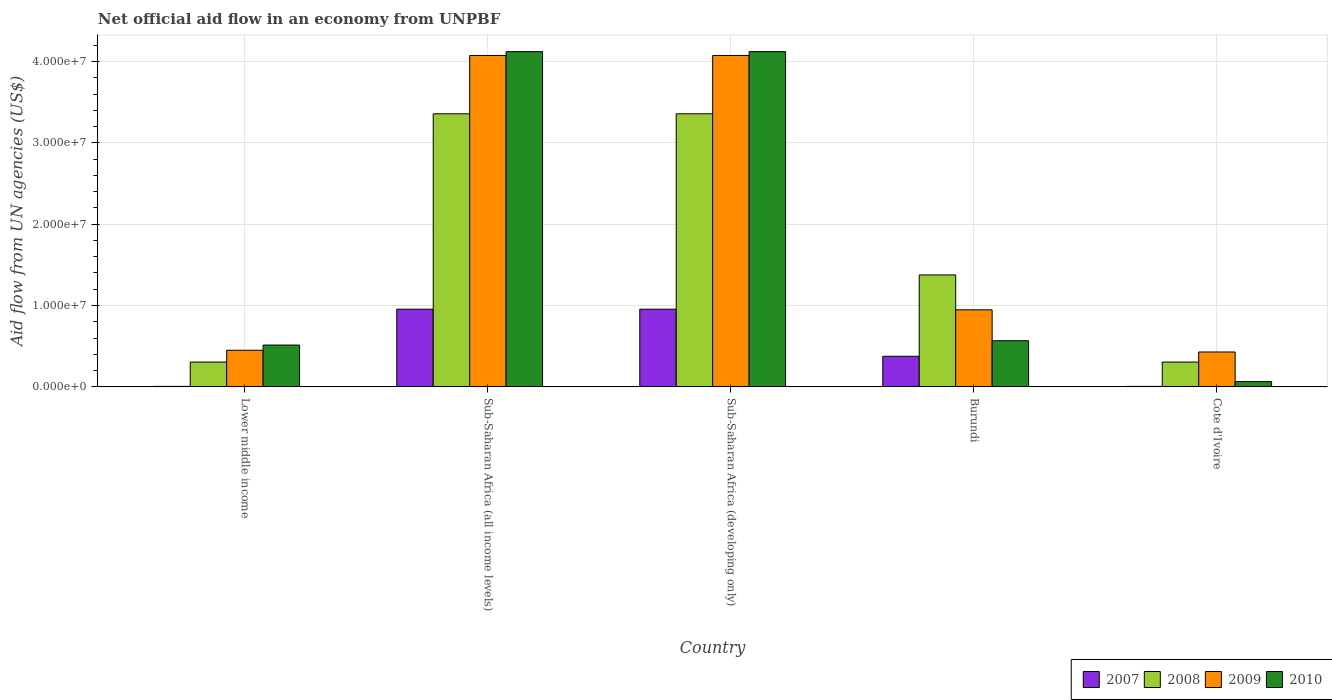How many different coloured bars are there?
Your response must be concise. 4. Are the number of bars per tick equal to the number of legend labels?
Your answer should be compact. Yes. Are the number of bars on each tick of the X-axis equal?
Make the answer very short. Yes. How many bars are there on the 5th tick from the left?
Offer a very short reply. 4. How many bars are there on the 3rd tick from the right?
Offer a very short reply. 4. What is the label of the 1st group of bars from the left?
Provide a short and direct response. Lower middle income. In how many cases, is the number of bars for a given country not equal to the number of legend labels?
Make the answer very short. 0. What is the net official aid flow in 2010 in Burundi?
Make the answer very short. 5.67e+06. Across all countries, what is the maximum net official aid flow in 2010?
Give a very brief answer. 4.12e+07. Across all countries, what is the minimum net official aid flow in 2010?
Your response must be concise. 6.50e+05. In which country was the net official aid flow in 2010 maximum?
Make the answer very short. Sub-Saharan Africa (all income levels). In which country was the net official aid flow in 2008 minimum?
Provide a succinct answer. Lower middle income. What is the total net official aid flow in 2008 in the graph?
Offer a very short reply. 8.70e+07. What is the difference between the net official aid flow in 2009 in Burundi and that in Lower middle income?
Offer a terse response. 4.97e+06. What is the difference between the net official aid flow in 2008 in Sub-Saharan Africa (all income levels) and the net official aid flow in 2009 in Lower middle income?
Make the answer very short. 2.91e+07. What is the average net official aid flow in 2009 per country?
Provide a short and direct response. 1.99e+07. What is the difference between the net official aid flow of/in 2010 and net official aid flow of/in 2007 in Sub-Saharan Africa (developing only)?
Your response must be concise. 3.17e+07. In how many countries, is the net official aid flow in 2007 greater than 6000000 US$?
Ensure brevity in your answer.  2. What is the ratio of the net official aid flow in 2008 in Burundi to that in Sub-Saharan Africa (developing only)?
Provide a short and direct response. 0.41. Is the net official aid flow in 2010 in Cote d'Ivoire less than that in Sub-Saharan Africa (all income levels)?
Your answer should be very brief. Yes. Is the difference between the net official aid flow in 2010 in Burundi and Sub-Saharan Africa (developing only) greater than the difference between the net official aid flow in 2007 in Burundi and Sub-Saharan Africa (developing only)?
Offer a terse response. No. What is the difference between the highest and the second highest net official aid flow in 2009?
Provide a short and direct response. 3.13e+07. What is the difference between the highest and the lowest net official aid flow in 2008?
Your answer should be compact. 3.05e+07. In how many countries, is the net official aid flow in 2007 greater than the average net official aid flow in 2007 taken over all countries?
Make the answer very short. 2. What does the 2nd bar from the left in Sub-Saharan Africa (developing only) represents?
Your answer should be very brief. 2008. What does the 3rd bar from the right in Burundi represents?
Make the answer very short. 2008. Is it the case that in every country, the sum of the net official aid flow in 2010 and net official aid flow in 2009 is greater than the net official aid flow in 2008?
Offer a terse response. Yes. How many bars are there?
Offer a terse response. 20. What is the difference between two consecutive major ticks on the Y-axis?
Provide a short and direct response. 1.00e+07. Are the values on the major ticks of Y-axis written in scientific E-notation?
Provide a succinct answer. Yes. Does the graph contain any zero values?
Provide a short and direct response. No. Does the graph contain grids?
Give a very brief answer. Yes. How are the legend labels stacked?
Ensure brevity in your answer.  Horizontal. What is the title of the graph?
Make the answer very short. Net official aid flow in an economy from UNPBF. What is the label or title of the X-axis?
Give a very brief answer. Country. What is the label or title of the Y-axis?
Your answer should be very brief. Aid flow from UN agencies (US$). What is the Aid flow from UN agencies (US$) of 2008 in Lower middle income?
Make the answer very short. 3.05e+06. What is the Aid flow from UN agencies (US$) of 2009 in Lower middle income?
Make the answer very short. 4.50e+06. What is the Aid flow from UN agencies (US$) of 2010 in Lower middle income?
Make the answer very short. 5.14e+06. What is the Aid flow from UN agencies (US$) of 2007 in Sub-Saharan Africa (all income levels)?
Your answer should be compact. 9.55e+06. What is the Aid flow from UN agencies (US$) in 2008 in Sub-Saharan Africa (all income levels)?
Your answer should be compact. 3.36e+07. What is the Aid flow from UN agencies (US$) in 2009 in Sub-Saharan Africa (all income levels)?
Offer a terse response. 4.07e+07. What is the Aid flow from UN agencies (US$) of 2010 in Sub-Saharan Africa (all income levels)?
Your answer should be very brief. 4.12e+07. What is the Aid flow from UN agencies (US$) in 2007 in Sub-Saharan Africa (developing only)?
Keep it short and to the point. 9.55e+06. What is the Aid flow from UN agencies (US$) of 2008 in Sub-Saharan Africa (developing only)?
Provide a short and direct response. 3.36e+07. What is the Aid flow from UN agencies (US$) in 2009 in Sub-Saharan Africa (developing only)?
Your answer should be compact. 4.07e+07. What is the Aid flow from UN agencies (US$) in 2010 in Sub-Saharan Africa (developing only)?
Keep it short and to the point. 4.12e+07. What is the Aid flow from UN agencies (US$) of 2007 in Burundi?
Ensure brevity in your answer.  3.76e+06. What is the Aid flow from UN agencies (US$) in 2008 in Burundi?
Your answer should be very brief. 1.38e+07. What is the Aid flow from UN agencies (US$) in 2009 in Burundi?
Provide a short and direct response. 9.47e+06. What is the Aid flow from UN agencies (US$) of 2010 in Burundi?
Your answer should be very brief. 5.67e+06. What is the Aid flow from UN agencies (US$) of 2007 in Cote d'Ivoire?
Offer a very short reply. 6.00e+04. What is the Aid flow from UN agencies (US$) in 2008 in Cote d'Ivoire?
Ensure brevity in your answer.  3.05e+06. What is the Aid flow from UN agencies (US$) of 2009 in Cote d'Ivoire?
Your answer should be very brief. 4.29e+06. What is the Aid flow from UN agencies (US$) in 2010 in Cote d'Ivoire?
Provide a succinct answer. 6.50e+05. Across all countries, what is the maximum Aid flow from UN agencies (US$) in 2007?
Offer a terse response. 9.55e+06. Across all countries, what is the maximum Aid flow from UN agencies (US$) of 2008?
Provide a short and direct response. 3.36e+07. Across all countries, what is the maximum Aid flow from UN agencies (US$) of 2009?
Offer a terse response. 4.07e+07. Across all countries, what is the maximum Aid flow from UN agencies (US$) in 2010?
Keep it short and to the point. 4.12e+07. Across all countries, what is the minimum Aid flow from UN agencies (US$) of 2008?
Your answer should be very brief. 3.05e+06. Across all countries, what is the minimum Aid flow from UN agencies (US$) in 2009?
Keep it short and to the point. 4.29e+06. Across all countries, what is the minimum Aid flow from UN agencies (US$) of 2010?
Your answer should be compact. 6.50e+05. What is the total Aid flow from UN agencies (US$) in 2007 in the graph?
Your response must be concise. 2.30e+07. What is the total Aid flow from UN agencies (US$) in 2008 in the graph?
Offer a very short reply. 8.70e+07. What is the total Aid flow from UN agencies (US$) of 2009 in the graph?
Your answer should be compact. 9.97e+07. What is the total Aid flow from UN agencies (US$) in 2010 in the graph?
Give a very brief answer. 9.39e+07. What is the difference between the Aid flow from UN agencies (US$) of 2007 in Lower middle income and that in Sub-Saharan Africa (all income levels)?
Provide a succinct answer. -9.49e+06. What is the difference between the Aid flow from UN agencies (US$) of 2008 in Lower middle income and that in Sub-Saharan Africa (all income levels)?
Your response must be concise. -3.05e+07. What is the difference between the Aid flow from UN agencies (US$) of 2009 in Lower middle income and that in Sub-Saharan Africa (all income levels)?
Ensure brevity in your answer.  -3.62e+07. What is the difference between the Aid flow from UN agencies (US$) of 2010 in Lower middle income and that in Sub-Saharan Africa (all income levels)?
Keep it short and to the point. -3.61e+07. What is the difference between the Aid flow from UN agencies (US$) of 2007 in Lower middle income and that in Sub-Saharan Africa (developing only)?
Provide a short and direct response. -9.49e+06. What is the difference between the Aid flow from UN agencies (US$) of 2008 in Lower middle income and that in Sub-Saharan Africa (developing only)?
Give a very brief answer. -3.05e+07. What is the difference between the Aid flow from UN agencies (US$) of 2009 in Lower middle income and that in Sub-Saharan Africa (developing only)?
Make the answer very short. -3.62e+07. What is the difference between the Aid flow from UN agencies (US$) in 2010 in Lower middle income and that in Sub-Saharan Africa (developing only)?
Your answer should be compact. -3.61e+07. What is the difference between the Aid flow from UN agencies (US$) in 2007 in Lower middle income and that in Burundi?
Offer a very short reply. -3.70e+06. What is the difference between the Aid flow from UN agencies (US$) in 2008 in Lower middle income and that in Burundi?
Your answer should be very brief. -1.07e+07. What is the difference between the Aid flow from UN agencies (US$) of 2009 in Lower middle income and that in Burundi?
Your answer should be very brief. -4.97e+06. What is the difference between the Aid flow from UN agencies (US$) of 2010 in Lower middle income and that in Burundi?
Your response must be concise. -5.30e+05. What is the difference between the Aid flow from UN agencies (US$) of 2007 in Lower middle income and that in Cote d'Ivoire?
Make the answer very short. 0. What is the difference between the Aid flow from UN agencies (US$) in 2010 in Lower middle income and that in Cote d'Ivoire?
Provide a succinct answer. 4.49e+06. What is the difference between the Aid flow from UN agencies (US$) of 2007 in Sub-Saharan Africa (all income levels) and that in Sub-Saharan Africa (developing only)?
Your response must be concise. 0. What is the difference between the Aid flow from UN agencies (US$) in 2009 in Sub-Saharan Africa (all income levels) and that in Sub-Saharan Africa (developing only)?
Keep it short and to the point. 0. What is the difference between the Aid flow from UN agencies (US$) in 2007 in Sub-Saharan Africa (all income levels) and that in Burundi?
Your answer should be very brief. 5.79e+06. What is the difference between the Aid flow from UN agencies (US$) in 2008 in Sub-Saharan Africa (all income levels) and that in Burundi?
Provide a succinct answer. 1.98e+07. What is the difference between the Aid flow from UN agencies (US$) of 2009 in Sub-Saharan Africa (all income levels) and that in Burundi?
Ensure brevity in your answer.  3.13e+07. What is the difference between the Aid flow from UN agencies (US$) of 2010 in Sub-Saharan Africa (all income levels) and that in Burundi?
Your answer should be compact. 3.55e+07. What is the difference between the Aid flow from UN agencies (US$) of 2007 in Sub-Saharan Africa (all income levels) and that in Cote d'Ivoire?
Your answer should be compact. 9.49e+06. What is the difference between the Aid flow from UN agencies (US$) of 2008 in Sub-Saharan Africa (all income levels) and that in Cote d'Ivoire?
Keep it short and to the point. 3.05e+07. What is the difference between the Aid flow from UN agencies (US$) of 2009 in Sub-Saharan Africa (all income levels) and that in Cote d'Ivoire?
Offer a terse response. 3.64e+07. What is the difference between the Aid flow from UN agencies (US$) in 2010 in Sub-Saharan Africa (all income levels) and that in Cote d'Ivoire?
Keep it short and to the point. 4.06e+07. What is the difference between the Aid flow from UN agencies (US$) of 2007 in Sub-Saharan Africa (developing only) and that in Burundi?
Provide a succinct answer. 5.79e+06. What is the difference between the Aid flow from UN agencies (US$) of 2008 in Sub-Saharan Africa (developing only) and that in Burundi?
Provide a short and direct response. 1.98e+07. What is the difference between the Aid flow from UN agencies (US$) in 2009 in Sub-Saharan Africa (developing only) and that in Burundi?
Your answer should be compact. 3.13e+07. What is the difference between the Aid flow from UN agencies (US$) of 2010 in Sub-Saharan Africa (developing only) and that in Burundi?
Ensure brevity in your answer.  3.55e+07. What is the difference between the Aid flow from UN agencies (US$) in 2007 in Sub-Saharan Africa (developing only) and that in Cote d'Ivoire?
Offer a terse response. 9.49e+06. What is the difference between the Aid flow from UN agencies (US$) in 2008 in Sub-Saharan Africa (developing only) and that in Cote d'Ivoire?
Your response must be concise. 3.05e+07. What is the difference between the Aid flow from UN agencies (US$) in 2009 in Sub-Saharan Africa (developing only) and that in Cote d'Ivoire?
Ensure brevity in your answer.  3.64e+07. What is the difference between the Aid flow from UN agencies (US$) in 2010 in Sub-Saharan Africa (developing only) and that in Cote d'Ivoire?
Make the answer very short. 4.06e+07. What is the difference between the Aid flow from UN agencies (US$) in 2007 in Burundi and that in Cote d'Ivoire?
Keep it short and to the point. 3.70e+06. What is the difference between the Aid flow from UN agencies (US$) of 2008 in Burundi and that in Cote d'Ivoire?
Offer a very short reply. 1.07e+07. What is the difference between the Aid flow from UN agencies (US$) in 2009 in Burundi and that in Cote d'Ivoire?
Provide a short and direct response. 5.18e+06. What is the difference between the Aid flow from UN agencies (US$) in 2010 in Burundi and that in Cote d'Ivoire?
Your answer should be very brief. 5.02e+06. What is the difference between the Aid flow from UN agencies (US$) in 2007 in Lower middle income and the Aid flow from UN agencies (US$) in 2008 in Sub-Saharan Africa (all income levels)?
Provide a succinct answer. -3.35e+07. What is the difference between the Aid flow from UN agencies (US$) of 2007 in Lower middle income and the Aid flow from UN agencies (US$) of 2009 in Sub-Saharan Africa (all income levels)?
Your answer should be very brief. -4.07e+07. What is the difference between the Aid flow from UN agencies (US$) of 2007 in Lower middle income and the Aid flow from UN agencies (US$) of 2010 in Sub-Saharan Africa (all income levels)?
Provide a short and direct response. -4.12e+07. What is the difference between the Aid flow from UN agencies (US$) of 2008 in Lower middle income and the Aid flow from UN agencies (US$) of 2009 in Sub-Saharan Africa (all income levels)?
Your answer should be very brief. -3.77e+07. What is the difference between the Aid flow from UN agencies (US$) in 2008 in Lower middle income and the Aid flow from UN agencies (US$) in 2010 in Sub-Saharan Africa (all income levels)?
Offer a terse response. -3.82e+07. What is the difference between the Aid flow from UN agencies (US$) in 2009 in Lower middle income and the Aid flow from UN agencies (US$) in 2010 in Sub-Saharan Africa (all income levels)?
Make the answer very short. -3.67e+07. What is the difference between the Aid flow from UN agencies (US$) in 2007 in Lower middle income and the Aid flow from UN agencies (US$) in 2008 in Sub-Saharan Africa (developing only)?
Give a very brief answer. -3.35e+07. What is the difference between the Aid flow from UN agencies (US$) in 2007 in Lower middle income and the Aid flow from UN agencies (US$) in 2009 in Sub-Saharan Africa (developing only)?
Make the answer very short. -4.07e+07. What is the difference between the Aid flow from UN agencies (US$) in 2007 in Lower middle income and the Aid flow from UN agencies (US$) in 2010 in Sub-Saharan Africa (developing only)?
Provide a short and direct response. -4.12e+07. What is the difference between the Aid flow from UN agencies (US$) in 2008 in Lower middle income and the Aid flow from UN agencies (US$) in 2009 in Sub-Saharan Africa (developing only)?
Ensure brevity in your answer.  -3.77e+07. What is the difference between the Aid flow from UN agencies (US$) in 2008 in Lower middle income and the Aid flow from UN agencies (US$) in 2010 in Sub-Saharan Africa (developing only)?
Keep it short and to the point. -3.82e+07. What is the difference between the Aid flow from UN agencies (US$) of 2009 in Lower middle income and the Aid flow from UN agencies (US$) of 2010 in Sub-Saharan Africa (developing only)?
Give a very brief answer. -3.67e+07. What is the difference between the Aid flow from UN agencies (US$) of 2007 in Lower middle income and the Aid flow from UN agencies (US$) of 2008 in Burundi?
Your answer should be very brief. -1.37e+07. What is the difference between the Aid flow from UN agencies (US$) of 2007 in Lower middle income and the Aid flow from UN agencies (US$) of 2009 in Burundi?
Offer a very short reply. -9.41e+06. What is the difference between the Aid flow from UN agencies (US$) of 2007 in Lower middle income and the Aid flow from UN agencies (US$) of 2010 in Burundi?
Offer a very short reply. -5.61e+06. What is the difference between the Aid flow from UN agencies (US$) in 2008 in Lower middle income and the Aid flow from UN agencies (US$) in 2009 in Burundi?
Make the answer very short. -6.42e+06. What is the difference between the Aid flow from UN agencies (US$) of 2008 in Lower middle income and the Aid flow from UN agencies (US$) of 2010 in Burundi?
Your answer should be compact. -2.62e+06. What is the difference between the Aid flow from UN agencies (US$) of 2009 in Lower middle income and the Aid flow from UN agencies (US$) of 2010 in Burundi?
Offer a very short reply. -1.17e+06. What is the difference between the Aid flow from UN agencies (US$) in 2007 in Lower middle income and the Aid flow from UN agencies (US$) in 2008 in Cote d'Ivoire?
Make the answer very short. -2.99e+06. What is the difference between the Aid flow from UN agencies (US$) in 2007 in Lower middle income and the Aid flow from UN agencies (US$) in 2009 in Cote d'Ivoire?
Keep it short and to the point. -4.23e+06. What is the difference between the Aid flow from UN agencies (US$) in 2007 in Lower middle income and the Aid flow from UN agencies (US$) in 2010 in Cote d'Ivoire?
Ensure brevity in your answer.  -5.90e+05. What is the difference between the Aid flow from UN agencies (US$) of 2008 in Lower middle income and the Aid flow from UN agencies (US$) of 2009 in Cote d'Ivoire?
Give a very brief answer. -1.24e+06. What is the difference between the Aid flow from UN agencies (US$) in 2008 in Lower middle income and the Aid flow from UN agencies (US$) in 2010 in Cote d'Ivoire?
Ensure brevity in your answer.  2.40e+06. What is the difference between the Aid flow from UN agencies (US$) in 2009 in Lower middle income and the Aid flow from UN agencies (US$) in 2010 in Cote d'Ivoire?
Ensure brevity in your answer.  3.85e+06. What is the difference between the Aid flow from UN agencies (US$) of 2007 in Sub-Saharan Africa (all income levels) and the Aid flow from UN agencies (US$) of 2008 in Sub-Saharan Africa (developing only)?
Provide a succinct answer. -2.40e+07. What is the difference between the Aid flow from UN agencies (US$) of 2007 in Sub-Saharan Africa (all income levels) and the Aid flow from UN agencies (US$) of 2009 in Sub-Saharan Africa (developing only)?
Make the answer very short. -3.12e+07. What is the difference between the Aid flow from UN agencies (US$) in 2007 in Sub-Saharan Africa (all income levels) and the Aid flow from UN agencies (US$) in 2010 in Sub-Saharan Africa (developing only)?
Your answer should be compact. -3.17e+07. What is the difference between the Aid flow from UN agencies (US$) of 2008 in Sub-Saharan Africa (all income levels) and the Aid flow from UN agencies (US$) of 2009 in Sub-Saharan Africa (developing only)?
Provide a succinct answer. -7.17e+06. What is the difference between the Aid flow from UN agencies (US$) of 2008 in Sub-Saharan Africa (all income levels) and the Aid flow from UN agencies (US$) of 2010 in Sub-Saharan Africa (developing only)?
Your answer should be very brief. -7.64e+06. What is the difference between the Aid flow from UN agencies (US$) in 2009 in Sub-Saharan Africa (all income levels) and the Aid flow from UN agencies (US$) in 2010 in Sub-Saharan Africa (developing only)?
Ensure brevity in your answer.  -4.70e+05. What is the difference between the Aid flow from UN agencies (US$) of 2007 in Sub-Saharan Africa (all income levels) and the Aid flow from UN agencies (US$) of 2008 in Burundi?
Your answer should be compact. -4.21e+06. What is the difference between the Aid flow from UN agencies (US$) in 2007 in Sub-Saharan Africa (all income levels) and the Aid flow from UN agencies (US$) in 2009 in Burundi?
Your response must be concise. 8.00e+04. What is the difference between the Aid flow from UN agencies (US$) in 2007 in Sub-Saharan Africa (all income levels) and the Aid flow from UN agencies (US$) in 2010 in Burundi?
Your answer should be very brief. 3.88e+06. What is the difference between the Aid flow from UN agencies (US$) in 2008 in Sub-Saharan Africa (all income levels) and the Aid flow from UN agencies (US$) in 2009 in Burundi?
Give a very brief answer. 2.41e+07. What is the difference between the Aid flow from UN agencies (US$) in 2008 in Sub-Saharan Africa (all income levels) and the Aid flow from UN agencies (US$) in 2010 in Burundi?
Your answer should be very brief. 2.79e+07. What is the difference between the Aid flow from UN agencies (US$) of 2009 in Sub-Saharan Africa (all income levels) and the Aid flow from UN agencies (US$) of 2010 in Burundi?
Your response must be concise. 3.51e+07. What is the difference between the Aid flow from UN agencies (US$) in 2007 in Sub-Saharan Africa (all income levels) and the Aid flow from UN agencies (US$) in 2008 in Cote d'Ivoire?
Keep it short and to the point. 6.50e+06. What is the difference between the Aid flow from UN agencies (US$) in 2007 in Sub-Saharan Africa (all income levels) and the Aid flow from UN agencies (US$) in 2009 in Cote d'Ivoire?
Offer a terse response. 5.26e+06. What is the difference between the Aid flow from UN agencies (US$) in 2007 in Sub-Saharan Africa (all income levels) and the Aid flow from UN agencies (US$) in 2010 in Cote d'Ivoire?
Give a very brief answer. 8.90e+06. What is the difference between the Aid flow from UN agencies (US$) in 2008 in Sub-Saharan Africa (all income levels) and the Aid flow from UN agencies (US$) in 2009 in Cote d'Ivoire?
Give a very brief answer. 2.93e+07. What is the difference between the Aid flow from UN agencies (US$) of 2008 in Sub-Saharan Africa (all income levels) and the Aid flow from UN agencies (US$) of 2010 in Cote d'Ivoire?
Offer a very short reply. 3.29e+07. What is the difference between the Aid flow from UN agencies (US$) of 2009 in Sub-Saharan Africa (all income levels) and the Aid flow from UN agencies (US$) of 2010 in Cote d'Ivoire?
Your response must be concise. 4.01e+07. What is the difference between the Aid flow from UN agencies (US$) in 2007 in Sub-Saharan Africa (developing only) and the Aid flow from UN agencies (US$) in 2008 in Burundi?
Your answer should be compact. -4.21e+06. What is the difference between the Aid flow from UN agencies (US$) in 2007 in Sub-Saharan Africa (developing only) and the Aid flow from UN agencies (US$) in 2010 in Burundi?
Make the answer very short. 3.88e+06. What is the difference between the Aid flow from UN agencies (US$) in 2008 in Sub-Saharan Africa (developing only) and the Aid flow from UN agencies (US$) in 2009 in Burundi?
Your answer should be very brief. 2.41e+07. What is the difference between the Aid flow from UN agencies (US$) in 2008 in Sub-Saharan Africa (developing only) and the Aid flow from UN agencies (US$) in 2010 in Burundi?
Provide a short and direct response. 2.79e+07. What is the difference between the Aid flow from UN agencies (US$) of 2009 in Sub-Saharan Africa (developing only) and the Aid flow from UN agencies (US$) of 2010 in Burundi?
Offer a terse response. 3.51e+07. What is the difference between the Aid flow from UN agencies (US$) of 2007 in Sub-Saharan Africa (developing only) and the Aid flow from UN agencies (US$) of 2008 in Cote d'Ivoire?
Your answer should be very brief. 6.50e+06. What is the difference between the Aid flow from UN agencies (US$) of 2007 in Sub-Saharan Africa (developing only) and the Aid flow from UN agencies (US$) of 2009 in Cote d'Ivoire?
Keep it short and to the point. 5.26e+06. What is the difference between the Aid flow from UN agencies (US$) in 2007 in Sub-Saharan Africa (developing only) and the Aid flow from UN agencies (US$) in 2010 in Cote d'Ivoire?
Ensure brevity in your answer.  8.90e+06. What is the difference between the Aid flow from UN agencies (US$) of 2008 in Sub-Saharan Africa (developing only) and the Aid flow from UN agencies (US$) of 2009 in Cote d'Ivoire?
Your response must be concise. 2.93e+07. What is the difference between the Aid flow from UN agencies (US$) in 2008 in Sub-Saharan Africa (developing only) and the Aid flow from UN agencies (US$) in 2010 in Cote d'Ivoire?
Your response must be concise. 3.29e+07. What is the difference between the Aid flow from UN agencies (US$) in 2009 in Sub-Saharan Africa (developing only) and the Aid flow from UN agencies (US$) in 2010 in Cote d'Ivoire?
Keep it short and to the point. 4.01e+07. What is the difference between the Aid flow from UN agencies (US$) in 2007 in Burundi and the Aid flow from UN agencies (US$) in 2008 in Cote d'Ivoire?
Keep it short and to the point. 7.10e+05. What is the difference between the Aid flow from UN agencies (US$) in 2007 in Burundi and the Aid flow from UN agencies (US$) in 2009 in Cote d'Ivoire?
Your response must be concise. -5.30e+05. What is the difference between the Aid flow from UN agencies (US$) of 2007 in Burundi and the Aid flow from UN agencies (US$) of 2010 in Cote d'Ivoire?
Your answer should be very brief. 3.11e+06. What is the difference between the Aid flow from UN agencies (US$) in 2008 in Burundi and the Aid flow from UN agencies (US$) in 2009 in Cote d'Ivoire?
Your response must be concise. 9.47e+06. What is the difference between the Aid flow from UN agencies (US$) in 2008 in Burundi and the Aid flow from UN agencies (US$) in 2010 in Cote d'Ivoire?
Your answer should be compact. 1.31e+07. What is the difference between the Aid flow from UN agencies (US$) in 2009 in Burundi and the Aid flow from UN agencies (US$) in 2010 in Cote d'Ivoire?
Ensure brevity in your answer.  8.82e+06. What is the average Aid flow from UN agencies (US$) in 2007 per country?
Give a very brief answer. 4.60e+06. What is the average Aid flow from UN agencies (US$) of 2008 per country?
Offer a terse response. 1.74e+07. What is the average Aid flow from UN agencies (US$) in 2009 per country?
Offer a terse response. 1.99e+07. What is the average Aid flow from UN agencies (US$) of 2010 per country?
Your response must be concise. 1.88e+07. What is the difference between the Aid flow from UN agencies (US$) in 2007 and Aid flow from UN agencies (US$) in 2008 in Lower middle income?
Offer a terse response. -2.99e+06. What is the difference between the Aid flow from UN agencies (US$) in 2007 and Aid flow from UN agencies (US$) in 2009 in Lower middle income?
Give a very brief answer. -4.44e+06. What is the difference between the Aid flow from UN agencies (US$) in 2007 and Aid flow from UN agencies (US$) in 2010 in Lower middle income?
Offer a terse response. -5.08e+06. What is the difference between the Aid flow from UN agencies (US$) of 2008 and Aid flow from UN agencies (US$) of 2009 in Lower middle income?
Your response must be concise. -1.45e+06. What is the difference between the Aid flow from UN agencies (US$) in 2008 and Aid flow from UN agencies (US$) in 2010 in Lower middle income?
Offer a very short reply. -2.09e+06. What is the difference between the Aid flow from UN agencies (US$) in 2009 and Aid flow from UN agencies (US$) in 2010 in Lower middle income?
Provide a short and direct response. -6.40e+05. What is the difference between the Aid flow from UN agencies (US$) in 2007 and Aid flow from UN agencies (US$) in 2008 in Sub-Saharan Africa (all income levels)?
Give a very brief answer. -2.40e+07. What is the difference between the Aid flow from UN agencies (US$) of 2007 and Aid flow from UN agencies (US$) of 2009 in Sub-Saharan Africa (all income levels)?
Your answer should be compact. -3.12e+07. What is the difference between the Aid flow from UN agencies (US$) of 2007 and Aid flow from UN agencies (US$) of 2010 in Sub-Saharan Africa (all income levels)?
Give a very brief answer. -3.17e+07. What is the difference between the Aid flow from UN agencies (US$) in 2008 and Aid flow from UN agencies (US$) in 2009 in Sub-Saharan Africa (all income levels)?
Ensure brevity in your answer.  -7.17e+06. What is the difference between the Aid flow from UN agencies (US$) of 2008 and Aid flow from UN agencies (US$) of 2010 in Sub-Saharan Africa (all income levels)?
Make the answer very short. -7.64e+06. What is the difference between the Aid flow from UN agencies (US$) of 2009 and Aid flow from UN agencies (US$) of 2010 in Sub-Saharan Africa (all income levels)?
Your answer should be very brief. -4.70e+05. What is the difference between the Aid flow from UN agencies (US$) in 2007 and Aid flow from UN agencies (US$) in 2008 in Sub-Saharan Africa (developing only)?
Give a very brief answer. -2.40e+07. What is the difference between the Aid flow from UN agencies (US$) of 2007 and Aid flow from UN agencies (US$) of 2009 in Sub-Saharan Africa (developing only)?
Offer a terse response. -3.12e+07. What is the difference between the Aid flow from UN agencies (US$) of 2007 and Aid flow from UN agencies (US$) of 2010 in Sub-Saharan Africa (developing only)?
Offer a terse response. -3.17e+07. What is the difference between the Aid flow from UN agencies (US$) of 2008 and Aid flow from UN agencies (US$) of 2009 in Sub-Saharan Africa (developing only)?
Your answer should be compact. -7.17e+06. What is the difference between the Aid flow from UN agencies (US$) in 2008 and Aid flow from UN agencies (US$) in 2010 in Sub-Saharan Africa (developing only)?
Your answer should be compact. -7.64e+06. What is the difference between the Aid flow from UN agencies (US$) of 2009 and Aid flow from UN agencies (US$) of 2010 in Sub-Saharan Africa (developing only)?
Provide a succinct answer. -4.70e+05. What is the difference between the Aid flow from UN agencies (US$) of 2007 and Aid flow from UN agencies (US$) of 2008 in Burundi?
Ensure brevity in your answer.  -1.00e+07. What is the difference between the Aid flow from UN agencies (US$) of 2007 and Aid flow from UN agencies (US$) of 2009 in Burundi?
Keep it short and to the point. -5.71e+06. What is the difference between the Aid flow from UN agencies (US$) of 2007 and Aid flow from UN agencies (US$) of 2010 in Burundi?
Offer a terse response. -1.91e+06. What is the difference between the Aid flow from UN agencies (US$) of 2008 and Aid flow from UN agencies (US$) of 2009 in Burundi?
Your answer should be very brief. 4.29e+06. What is the difference between the Aid flow from UN agencies (US$) of 2008 and Aid flow from UN agencies (US$) of 2010 in Burundi?
Provide a short and direct response. 8.09e+06. What is the difference between the Aid flow from UN agencies (US$) of 2009 and Aid flow from UN agencies (US$) of 2010 in Burundi?
Your response must be concise. 3.80e+06. What is the difference between the Aid flow from UN agencies (US$) of 2007 and Aid flow from UN agencies (US$) of 2008 in Cote d'Ivoire?
Provide a succinct answer. -2.99e+06. What is the difference between the Aid flow from UN agencies (US$) of 2007 and Aid flow from UN agencies (US$) of 2009 in Cote d'Ivoire?
Offer a terse response. -4.23e+06. What is the difference between the Aid flow from UN agencies (US$) of 2007 and Aid flow from UN agencies (US$) of 2010 in Cote d'Ivoire?
Make the answer very short. -5.90e+05. What is the difference between the Aid flow from UN agencies (US$) of 2008 and Aid flow from UN agencies (US$) of 2009 in Cote d'Ivoire?
Make the answer very short. -1.24e+06. What is the difference between the Aid flow from UN agencies (US$) in 2008 and Aid flow from UN agencies (US$) in 2010 in Cote d'Ivoire?
Give a very brief answer. 2.40e+06. What is the difference between the Aid flow from UN agencies (US$) in 2009 and Aid flow from UN agencies (US$) in 2010 in Cote d'Ivoire?
Offer a very short reply. 3.64e+06. What is the ratio of the Aid flow from UN agencies (US$) of 2007 in Lower middle income to that in Sub-Saharan Africa (all income levels)?
Keep it short and to the point. 0.01. What is the ratio of the Aid flow from UN agencies (US$) of 2008 in Lower middle income to that in Sub-Saharan Africa (all income levels)?
Make the answer very short. 0.09. What is the ratio of the Aid flow from UN agencies (US$) of 2009 in Lower middle income to that in Sub-Saharan Africa (all income levels)?
Make the answer very short. 0.11. What is the ratio of the Aid flow from UN agencies (US$) in 2010 in Lower middle income to that in Sub-Saharan Africa (all income levels)?
Offer a terse response. 0.12. What is the ratio of the Aid flow from UN agencies (US$) of 2007 in Lower middle income to that in Sub-Saharan Africa (developing only)?
Your answer should be very brief. 0.01. What is the ratio of the Aid flow from UN agencies (US$) in 2008 in Lower middle income to that in Sub-Saharan Africa (developing only)?
Your answer should be compact. 0.09. What is the ratio of the Aid flow from UN agencies (US$) of 2009 in Lower middle income to that in Sub-Saharan Africa (developing only)?
Offer a very short reply. 0.11. What is the ratio of the Aid flow from UN agencies (US$) of 2010 in Lower middle income to that in Sub-Saharan Africa (developing only)?
Give a very brief answer. 0.12. What is the ratio of the Aid flow from UN agencies (US$) in 2007 in Lower middle income to that in Burundi?
Make the answer very short. 0.02. What is the ratio of the Aid flow from UN agencies (US$) of 2008 in Lower middle income to that in Burundi?
Ensure brevity in your answer.  0.22. What is the ratio of the Aid flow from UN agencies (US$) in 2009 in Lower middle income to that in Burundi?
Provide a succinct answer. 0.48. What is the ratio of the Aid flow from UN agencies (US$) in 2010 in Lower middle income to that in Burundi?
Ensure brevity in your answer.  0.91. What is the ratio of the Aid flow from UN agencies (US$) of 2008 in Lower middle income to that in Cote d'Ivoire?
Offer a terse response. 1. What is the ratio of the Aid flow from UN agencies (US$) in 2009 in Lower middle income to that in Cote d'Ivoire?
Keep it short and to the point. 1.05. What is the ratio of the Aid flow from UN agencies (US$) of 2010 in Lower middle income to that in Cote d'Ivoire?
Your answer should be compact. 7.91. What is the ratio of the Aid flow from UN agencies (US$) in 2010 in Sub-Saharan Africa (all income levels) to that in Sub-Saharan Africa (developing only)?
Give a very brief answer. 1. What is the ratio of the Aid flow from UN agencies (US$) of 2007 in Sub-Saharan Africa (all income levels) to that in Burundi?
Provide a short and direct response. 2.54. What is the ratio of the Aid flow from UN agencies (US$) of 2008 in Sub-Saharan Africa (all income levels) to that in Burundi?
Offer a terse response. 2.44. What is the ratio of the Aid flow from UN agencies (US$) in 2009 in Sub-Saharan Africa (all income levels) to that in Burundi?
Ensure brevity in your answer.  4.3. What is the ratio of the Aid flow from UN agencies (US$) in 2010 in Sub-Saharan Africa (all income levels) to that in Burundi?
Offer a terse response. 7.27. What is the ratio of the Aid flow from UN agencies (US$) of 2007 in Sub-Saharan Africa (all income levels) to that in Cote d'Ivoire?
Offer a very short reply. 159.17. What is the ratio of the Aid flow from UN agencies (US$) in 2008 in Sub-Saharan Africa (all income levels) to that in Cote d'Ivoire?
Offer a very short reply. 11.01. What is the ratio of the Aid flow from UN agencies (US$) in 2009 in Sub-Saharan Africa (all income levels) to that in Cote d'Ivoire?
Offer a very short reply. 9.5. What is the ratio of the Aid flow from UN agencies (US$) in 2010 in Sub-Saharan Africa (all income levels) to that in Cote d'Ivoire?
Provide a succinct answer. 63.4. What is the ratio of the Aid flow from UN agencies (US$) of 2007 in Sub-Saharan Africa (developing only) to that in Burundi?
Provide a short and direct response. 2.54. What is the ratio of the Aid flow from UN agencies (US$) of 2008 in Sub-Saharan Africa (developing only) to that in Burundi?
Make the answer very short. 2.44. What is the ratio of the Aid flow from UN agencies (US$) of 2009 in Sub-Saharan Africa (developing only) to that in Burundi?
Keep it short and to the point. 4.3. What is the ratio of the Aid flow from UN agencies (US$) of 2010 in Sub-Saharan Africa (developing only) to that in Burundi?
Your response must be concise. 7.27. What is the ratio of the Aid flow from UN agencies (US$) of 2007 in Sub-Saharan Africa (developing only) to that in Cote d'Ivoire?
Provide a short and direct response. 159.17. What is the ratio of the Aid flow from UN agencies (US$) in 2008 in Sub-Saharan Africa (developing only) to that in Cote d'Ivoire?
Make the answer very short. 11.01. What is the ratio of the Aid flow from UN agencies (US$) of 2009 in Sub-Saharan Africa (developing only) to that in Cote d'Ivoire?
Make the answer very short. 9.5. What is the ratio of the Aid flow from UN agencies (US$) in 2010 in Sub-Saharan Africa (developing only) to that in Cote d'Ivoire?
Provide a short and direct response. 63.4. What is the ratio of the Aid flow from UN agencies (US$) of 2007 in Burundi to that in Cote d'Ivoire?
Provide a succinct answer. 62.67. What is the ratio of the Aid flow from UN agencies (US$) of 2008 in Burundi to that in Cote d'Ivoire?
Keep it short and to the point. 4.51. What is the ratio of the Aid flow from UN agencies (US$) of 2009 in Burundi to that in Cote d'Ivoire?
Your response must be concise. 2.21. What is the ratio of the Aid flow from UN agencies (US$) of 2010 in Burundi to that in Cote d'Ivoire?
Offer a very short reply. 8.72. What is the difference between the highest and the second highest Aid flow from UN agencies (US$) in 2008?
Provide a succinct answer. 0. What is the difference between the highest and the second highest Aid flow from UN agencies (US$) of 2010?
Your response must be concise. 0. What is the difference between the highest and the lowest Aid flow from UN agencies (US$) in 2007?
Make the answer very short. 9.49e+06. What is the difference between the highest and the lowest Aid flow from UN agencies (US$) in 2008?
Your answer should be very brief. 3.05e+07. What is the difference between the highest and the lowest Aid flow from UN agencies (US$) in 2009?
Provide a succinct answer. 3.64e+07. What is the difference between the highest and the lowest Aid flow from UN agencies (US$) of 2010?
Make the answer very short. 4.06e+07. 